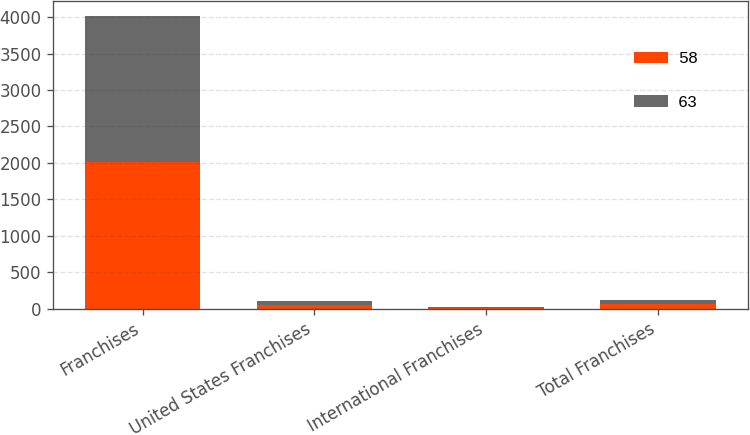<chart> <loc_0><loc_0><loc_500><loc_500><stacked_bar_chart><ecel><fcel>Franchises<fcel>United States Franchises<fcel>International Franchises<fcel>Total Franchises<nl><fcel>58<fcel>2008<fcel>52<fcel>11<fcel>63<nl><fcel>63<fcel>2007<fcel>51<fcel>7<fcel>58<nl></chart> 